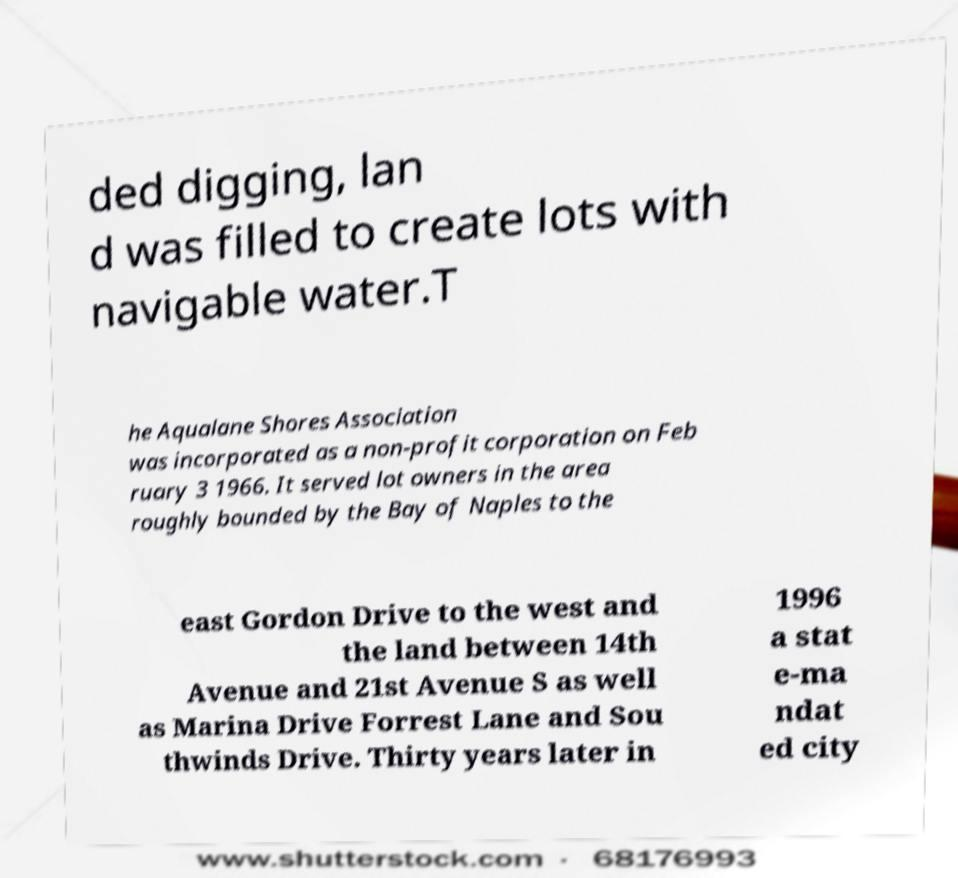Can you accurately transcribe the text from the provided image for me? ded digging, lan d was filled to create lots with navigable water.T he Aqualane Shores Association was incorporated as a non-profit corporation on Feb ruary 3 1966. It served lot owners in the area roughly bounded by the Bay of Naples to the east Gordon Drive to the west and the land between 14th Avenue and 21st Avenue S as well as Marina Drive Forrest Lane and Sou thwinds Drive. Thirty years later in 1996 a stat e-ma ndat ed city 